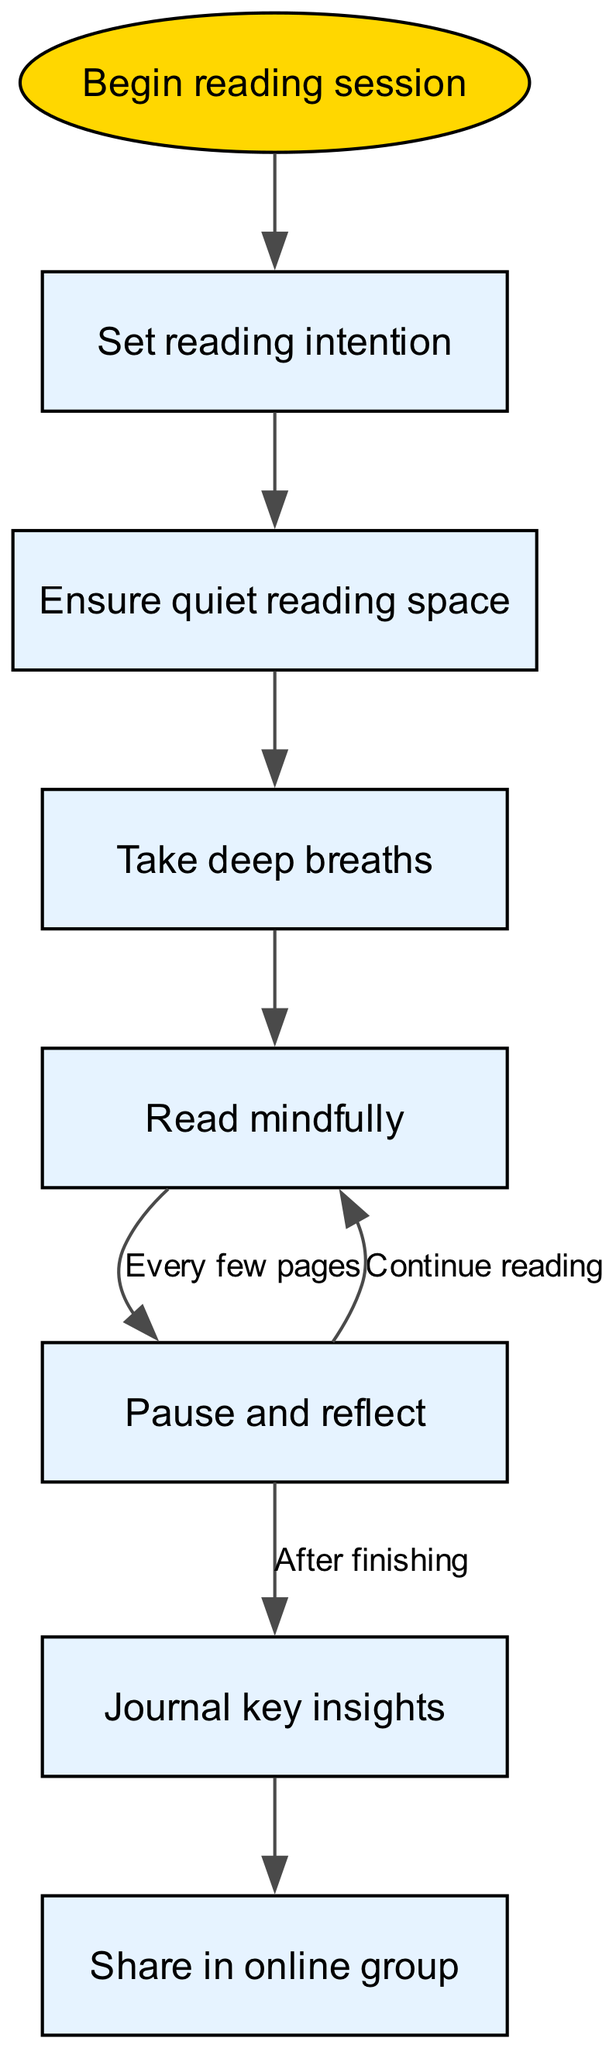What is the first step in the reading session? The diagram shows that the first step is "Begin reading session," indicating that it is the starting point of the mindfulness process while reading.
Answer: Begin reading session How many nodes are present in the diagram? By counting from the diagram, there are a total of 7 nodes, each representing a specific stage in the mindfulness reading process.
Answer: 7 What do you do after setting your reading intention? The flow from "setIntention" leads to "checkEnvironment," thus indicating that the next action is to ensure a suitable reading space.
Answer: Check environment What is the action to be taken every few pages while reading? The diagram specifies that the action is to "Pause and reflect" every few pages, which is a part of the mindfulness technique.
Answer: Pause and reflect What happens after journaling key insights? The diagram connects "journalInsights" to "discussGroup," signifying that the next step is to share insights in the online group.
Answer: Share in online group How does the reading process continue after reflecting? The diagram indicates that after pausing to reflect, the flow goes back to "readMindfully," suggesting that the reader should continue reading after reflection.
Answer: Continue reading How many edges are in the diagram? There are 8 edges in the flow chart, representing the connections between the various steps in the mindfulness reading process.
Answer: 8 What is the action you take after taking deep breaths? According to the diagram, after "deepBreath," you proceed to "readMindfully," which indicates that deep breathing prepares you for focused reading.
Answer: Read mindfully What is the final step in the process? The final node in the flow indicates that the last action is to "Share in online group," providing a social component to the reading experience.
Answer: Share in online group 